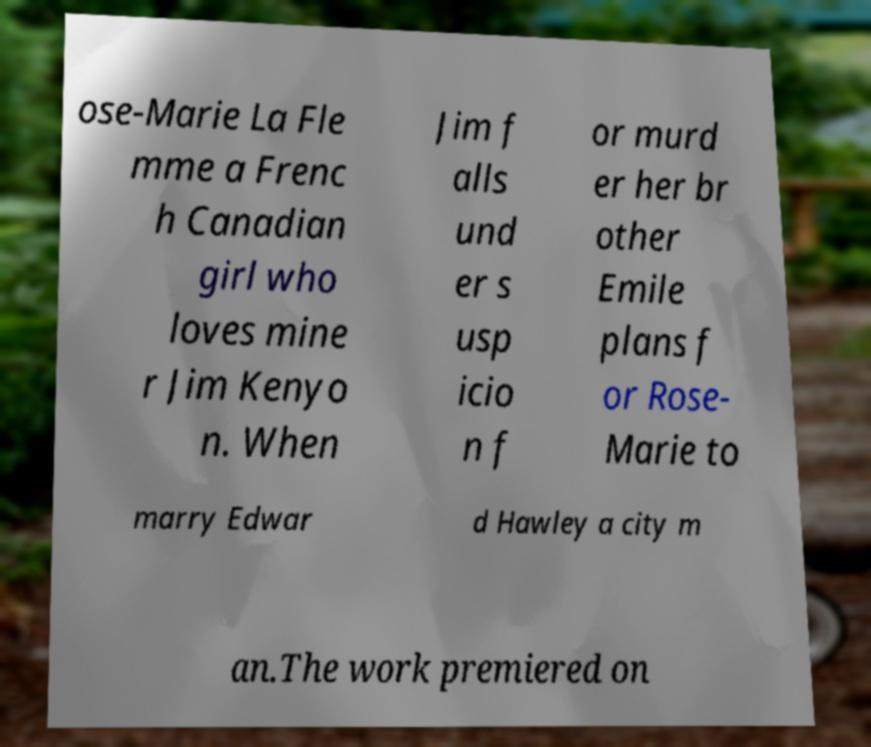Please read and relay the text visible in this image. What does it say? ose-Marie La Fle mme a Frenc h Canadian girl who loves mine r Jim Kenyo n. When Jim f alls und er s usp icio n f or murd er her br other Emile plans f or Rose- Marie to marry Edwar d Hawley a city m an.The work premiered on 